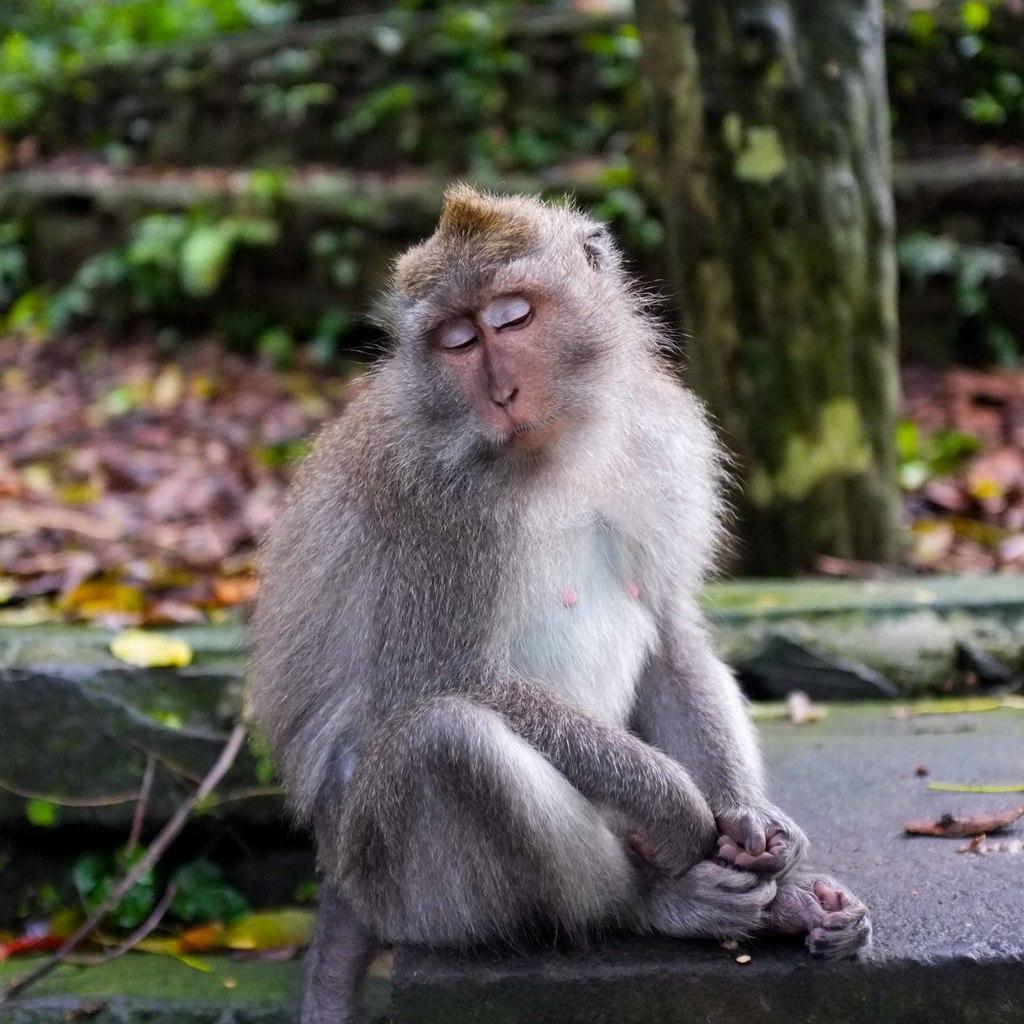How would you summarize this image in a sentence or two? There is one monkey sitting on the surface as we can see at the bottom of this image. We can see a bark of a tree on the right side of this image. 